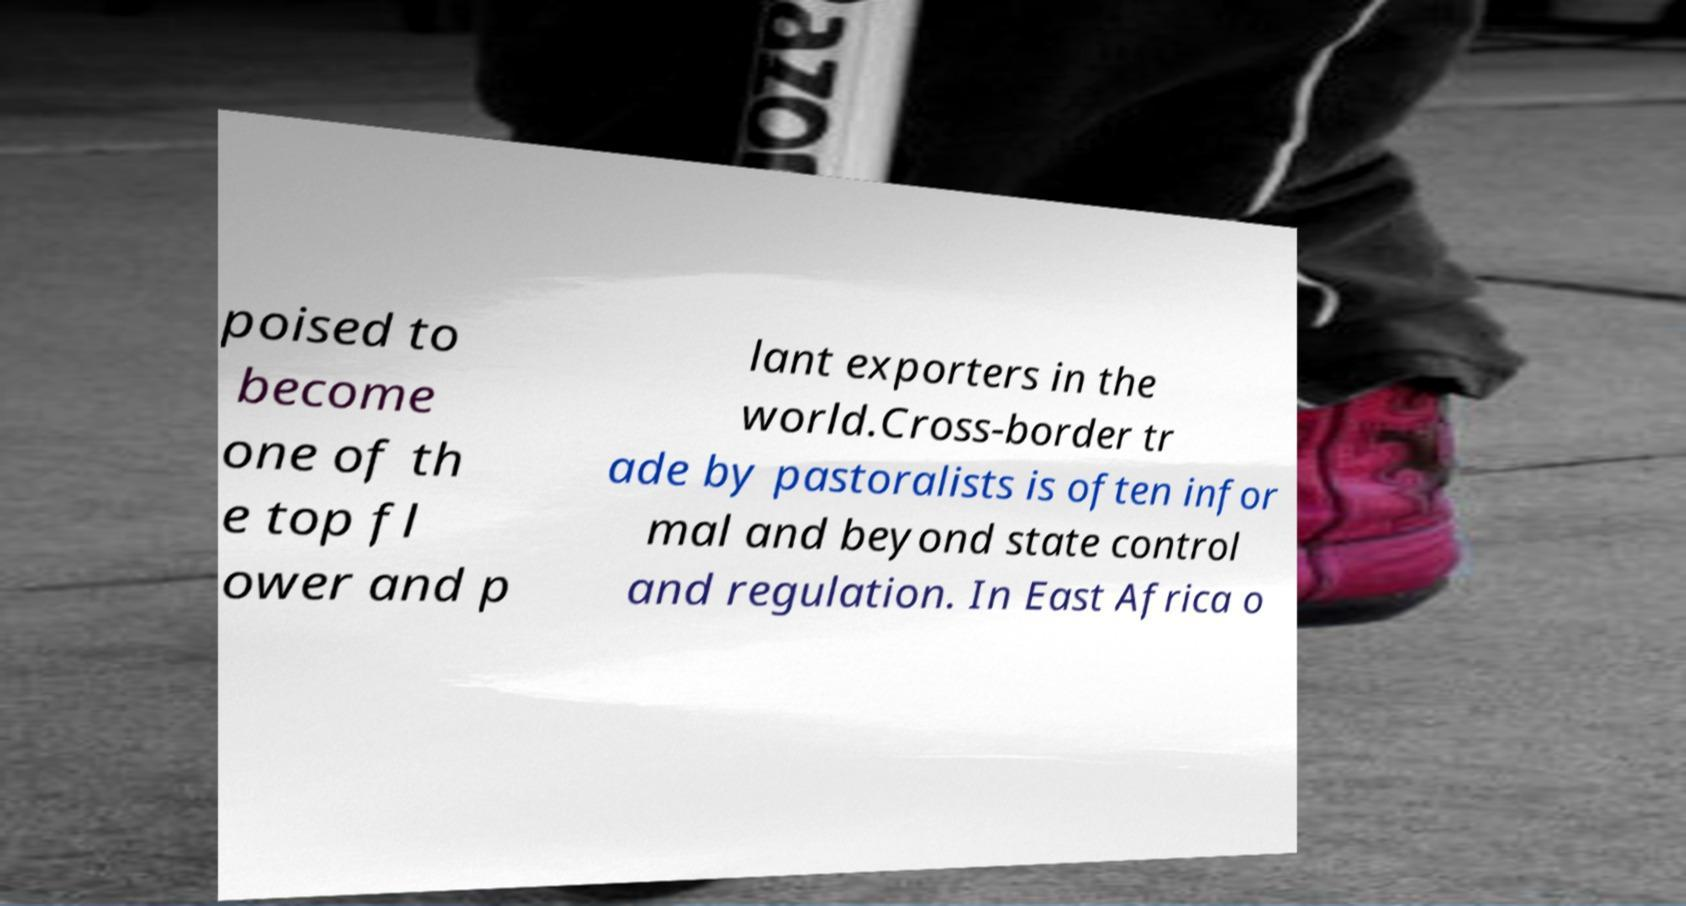What messages or text are displayed in this image? I need them in a readable, typed format. poised to become one of th e top fl ower and p lant exporters in the world.Cross-border tr ade by pastoralists is often infor mal and beyond state control and regulation. In East Africa o 